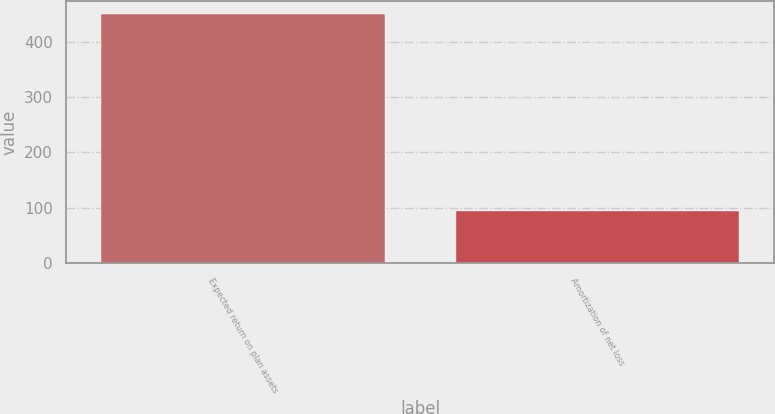Convert chart. <chart><loc_0><loc_0><loc_500><loc_500><bar_chart><fcel>Expected return on plan assets<fcel>Amortization of net loss<nl><fcel>450<fcel>94<nl></chart> 